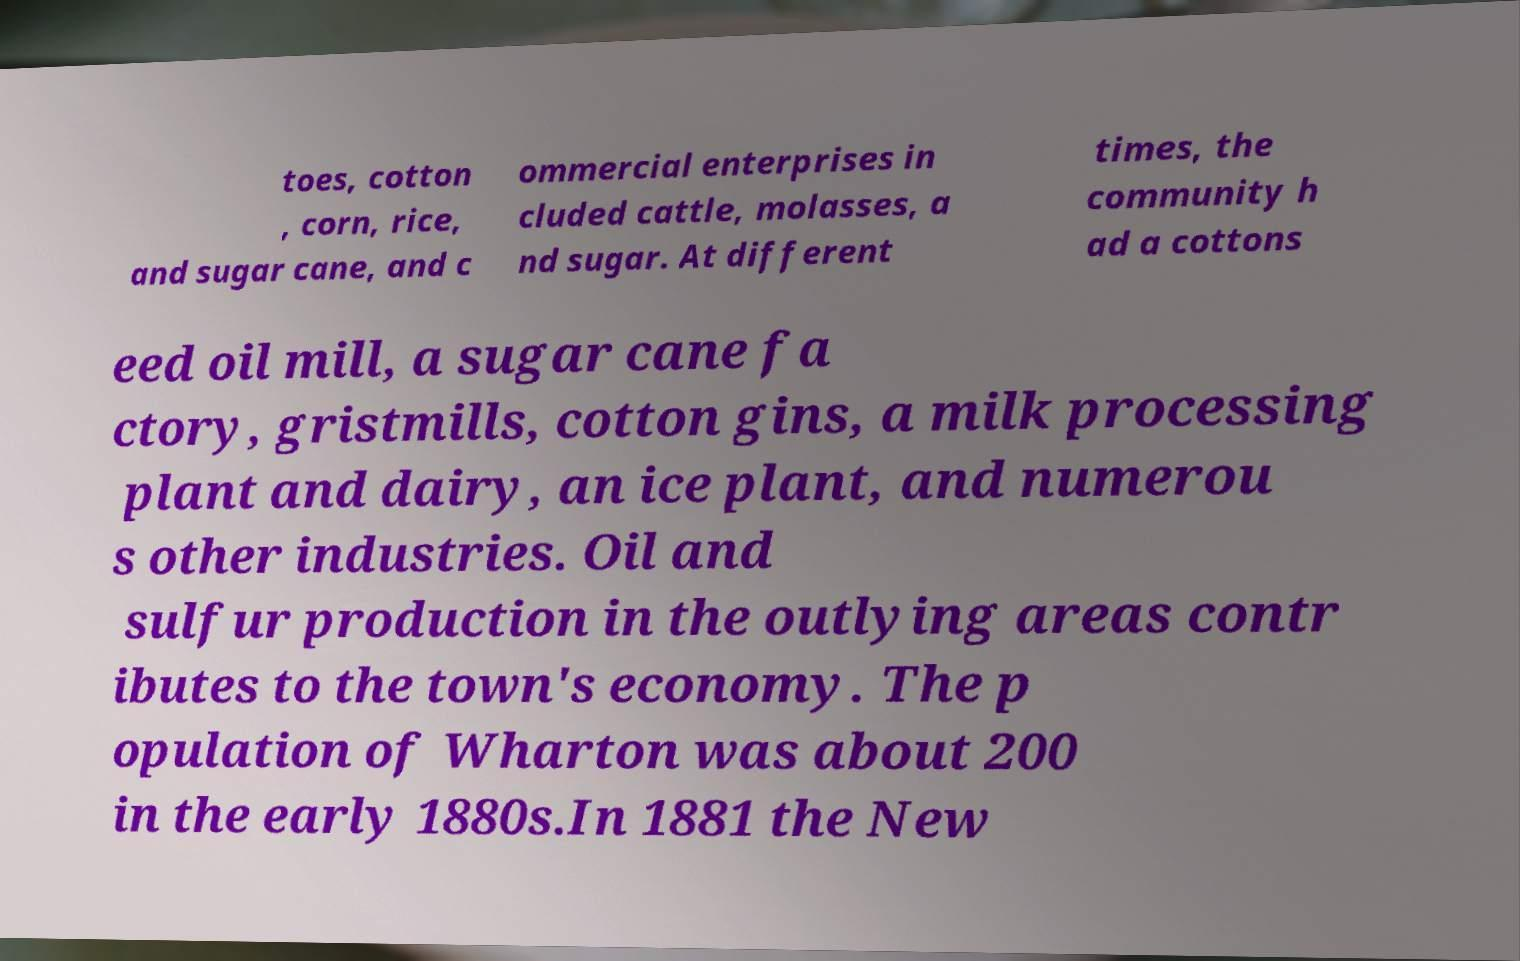Please read and relay the text visible in this image. What does it say? toes, cotton , corn, rice, and sugar cane, and c ommercial enterprises in cluded cattle, molasses, a nd sugar. At different times, the community h ad a cottons eed oil mill, a sugar cane fa ctory, gristmills, cotton gins, a milk processing plant and dairy, an ice plant, and numerou s other industries. Oil and sulfur production in the outlying areas contr ibutes to the town's economy. The p opulation of Wharton was about 200 in the early 1880s.In 1881 the New 